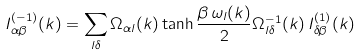Convert formula to latex. <formula><loc_0><loc_0><loc_500><loc_500>I _ { \alpha \beta } ^ { ( - 1 ) } ( k ) = \sum _ { l \delta } \Omega _ { \alpha l } ( k ) \tanh { \frac { \beta \, \omega _ { l } ( k ) } { 2 } } \Omega _ { l \delta } ^ { - 1 } ( k ) \, I _ { \delta \beta } ^ { ( 1 ) } ( k )</formula> 